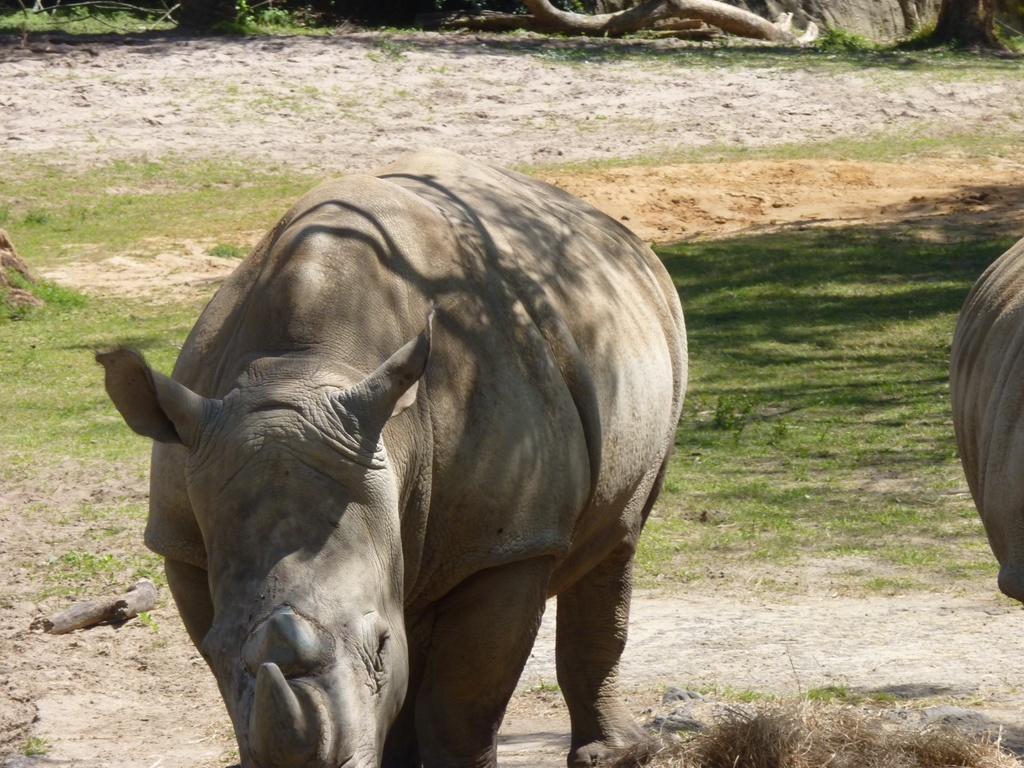Describe this image in one or two sentences. In this picture I can see few animals on the ground. 